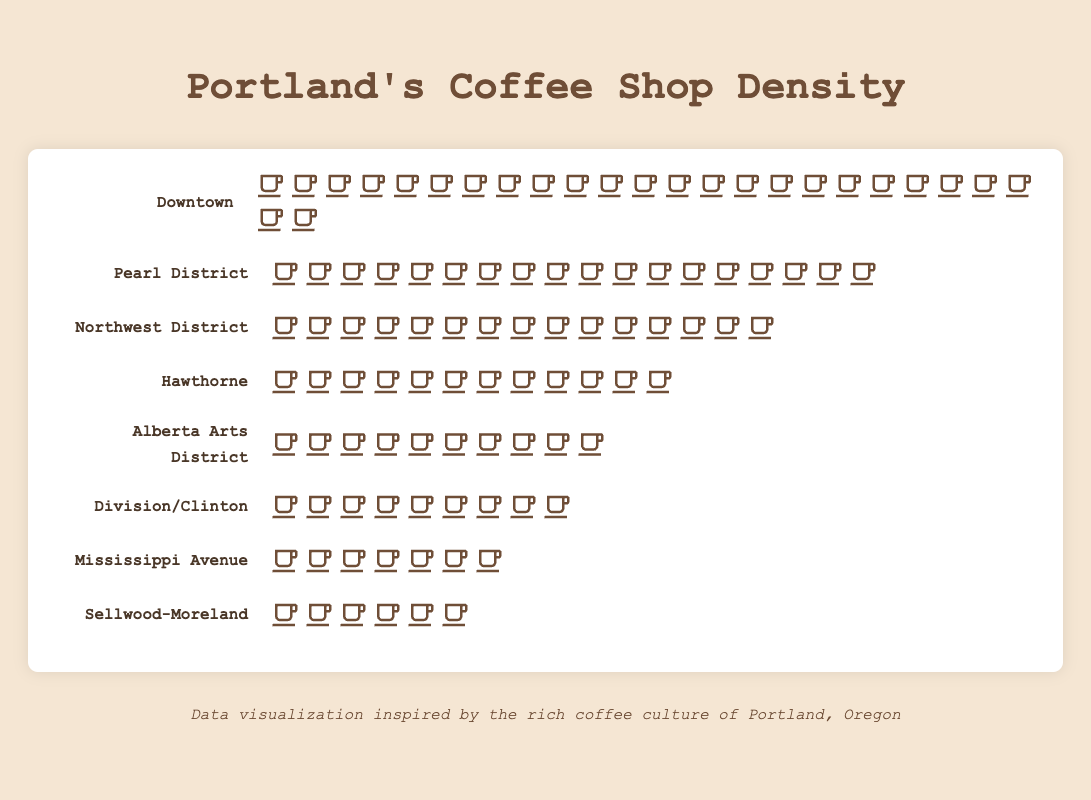What is the title of the figure? The title of the figure is positioned at the top center of the page. It reads "Portland's Coffee Shop Density".
Answer: Portland's Coffee Shop Density Which neighborhood has the highest number of coffee shops? By visually comparing the count of coffee cup icons for each neighborhood, Downtown has the highest number with 25 icons.
Answer: Downtown How many coffee shops are there in the Alberta Arts District? Count the number of coffee cup icons next to the Alberta Arts District label. There are 10 coffee cup icons.
Answer: 10 What is the total number of coffee shops in the Pearl District and Northwest District combined? The Pearl District has 18 coffee shops and the Northwest District has 15. Adding these together: 18 + 15 = 33
Answer: 33 Which neighborhood has more coffee shops, Hawthorne or Division/Clinton? Compare the number of coffee cup icons for Hawthorne (12) and Division/Clinton (9). Hawthorne has more coffee shops.
Answer: Hawthorne Rank the neighborhoods by coffee shop density from highest to lowest. First, identify the number of coffee shops in each neighborhood: Downtown (25), Pearl District (18), Northwest District (15), Hawthorne (12), Alberta Arts District (10), Division/Clinton (9), Mississippi Avenue (7), Sellwood-Moreland (6). Then, order them accordingly:
1. Downtown
2. Pearl District
3. Northwest District
4. Hawthorne
5. Alberta Arts District
6. Division/Clinton
7. Mississippi Avenue
8. Sellwood-Moreland
Answer: Downtown, Pearl District, Northwest District, Hawthorne, Alberta Arts District, Division/Clinton, Mississippi Avenue, Sellwood-Moreland What is the average number of coffee shops across all neighborhoods? Sum the number of coffee shops from all neighborhoods and divide by the number of neighborhoods: (25 + 18 + 15 + 12 + 10 + 9 + 7 + 6) / 8 = 102 / 8 = 12.75
Answer: 12.75 How many more coffee shops does Downtown have compared to Mississippi Avenue? Downtown has 25 coffee shops and Mississippi Avenue has 7. The difference is 25 - 7 = 18
Answer: 18 Is the number of coffee shops in Sellwood-Moreland less than in all other neighborhoods? Compare Sellwood-Moreland (6 coffee shops) with other neighborhoods: Downtown (25), Pearl District (18), Northwest District (15), Hawthorne (12), Alberta Arts District (10), Division/Clinton (9), Mississippi Avenue (7). Sellwood-Moreland has the least.
Answer: Yes What is the median number of coffee shops across all neighborhoods? List the numbers in ascending order: 6, 7, 9, 10, 12, 15, 18, 25. Since there are 8 neighborhoods, the median is the average of the 4th and 5th values: (10 + 12) / 2 = 11
Answer: 11 